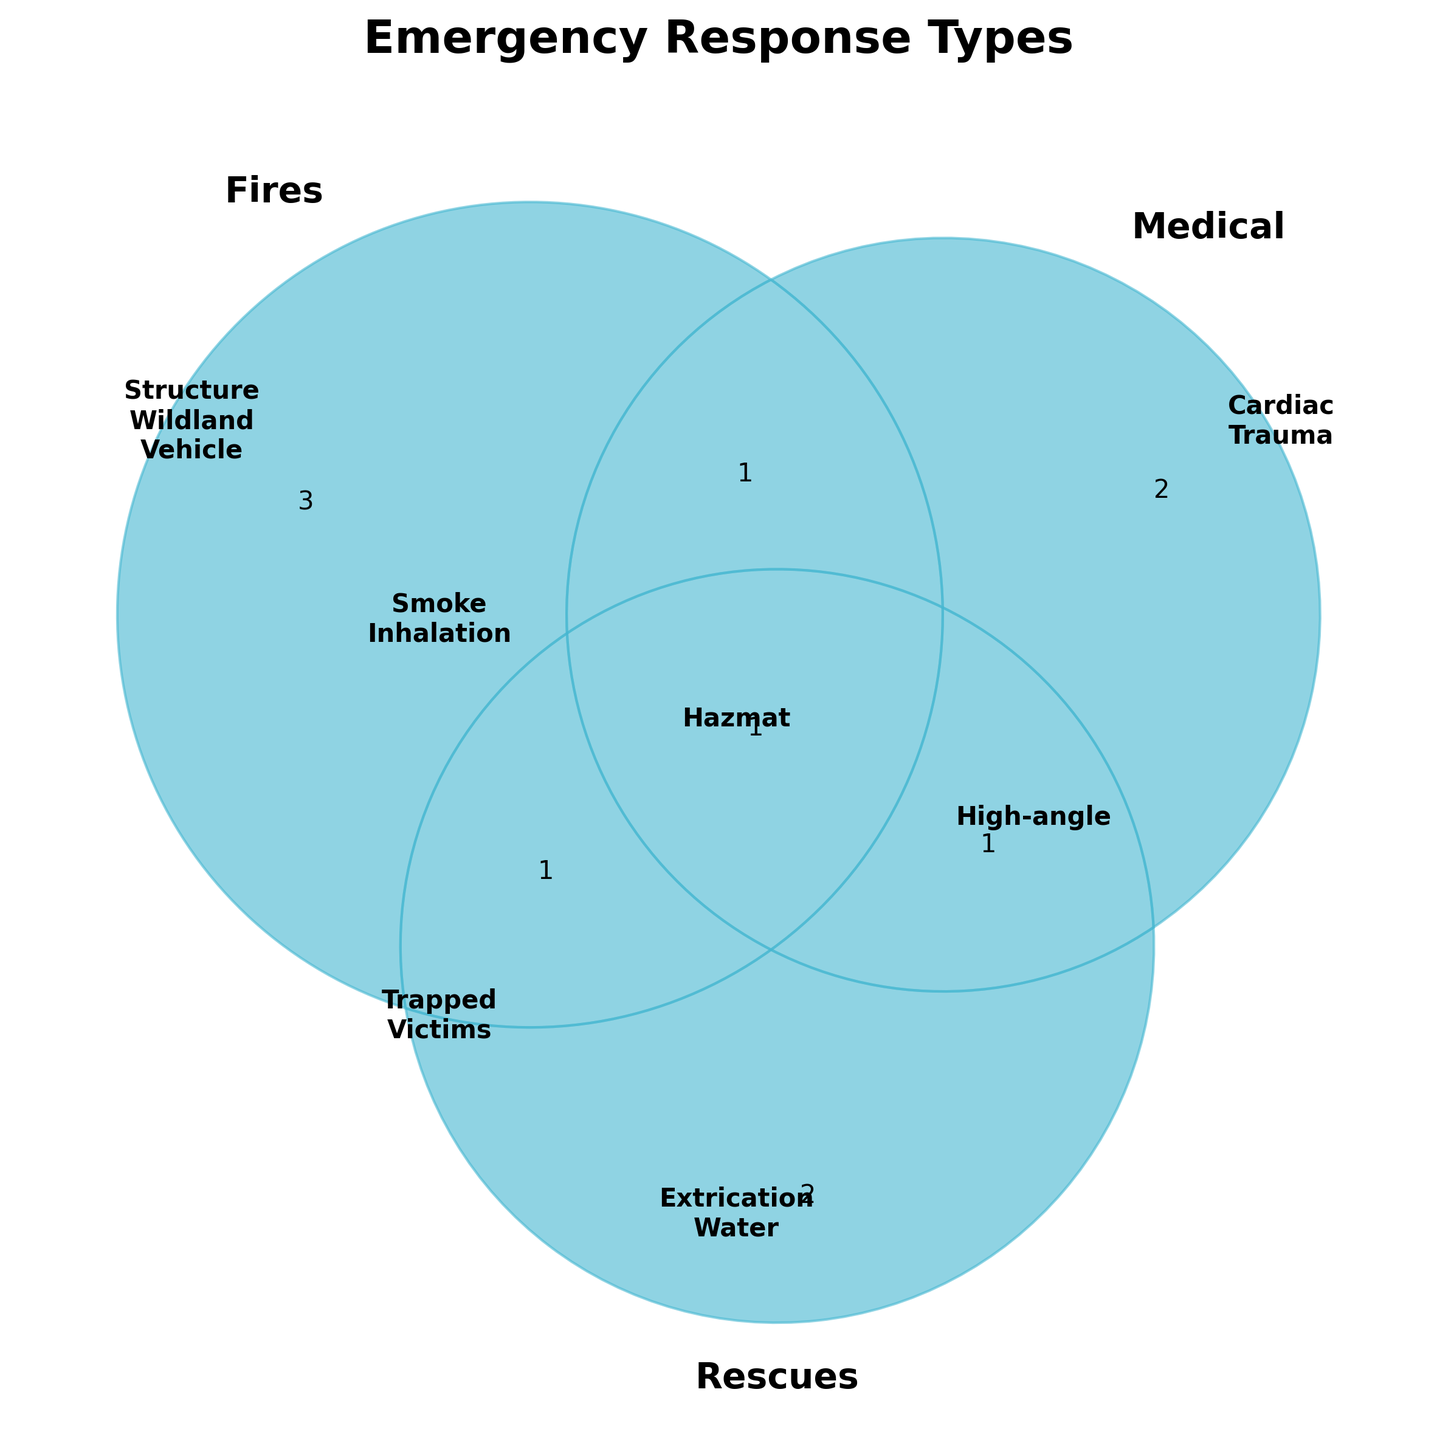What's the title of the Venn diagram? The title of the Venn diagram is located at the top center of the plot.
Answer: Emergency Response Types What color represents the 'Fires' category? The color associated with the 'Fires' category is the same color used for the segment and the associated text in the figure.
Answer: Red Which category contains 'Vehicle fires'? Locate the 'Vehicle fires' in the list of items within the 'Fires' section of the Venn diagram.
Answer: Fires Which category has more unique types: 'Medical' or 'Rescues'? Count the number of unique items listed within the 'Medical' and 'Rescues' sections to determine which has more.
Answer: Medical How many types of emergencies involve both 'Fires' and 'Medical'? Identify the overlapping section of the 'Fires' and 'Medical' circles and count the items listed there.
Answer: 1 Name all types that are shared between 'Fires' and 'Rescues'. Refer to the overlapping segment of 'Fires' and 'Rescues' on the diagram and list all items.
Answer: Trapped victims Which type of incident is common to 'Fires', 'Medical', and 'Rescues'? Look at the central section where all three circles intersect and list the item there.
Answer: Hazmat incidents Do 'Cardiac arrests' fall under 'Medical' alone or multiple categories? Examine the 'Medical' section to see if 'Cardiac arrests' is listed without being part of any overlap with other categories.
Answer: Medical Which is more common, items exclusive to 'Fires' or 'Rescues'? Compare the number of items that are exclusively within 'Fires' and 'Rescues' sections.
Answer: Fires 